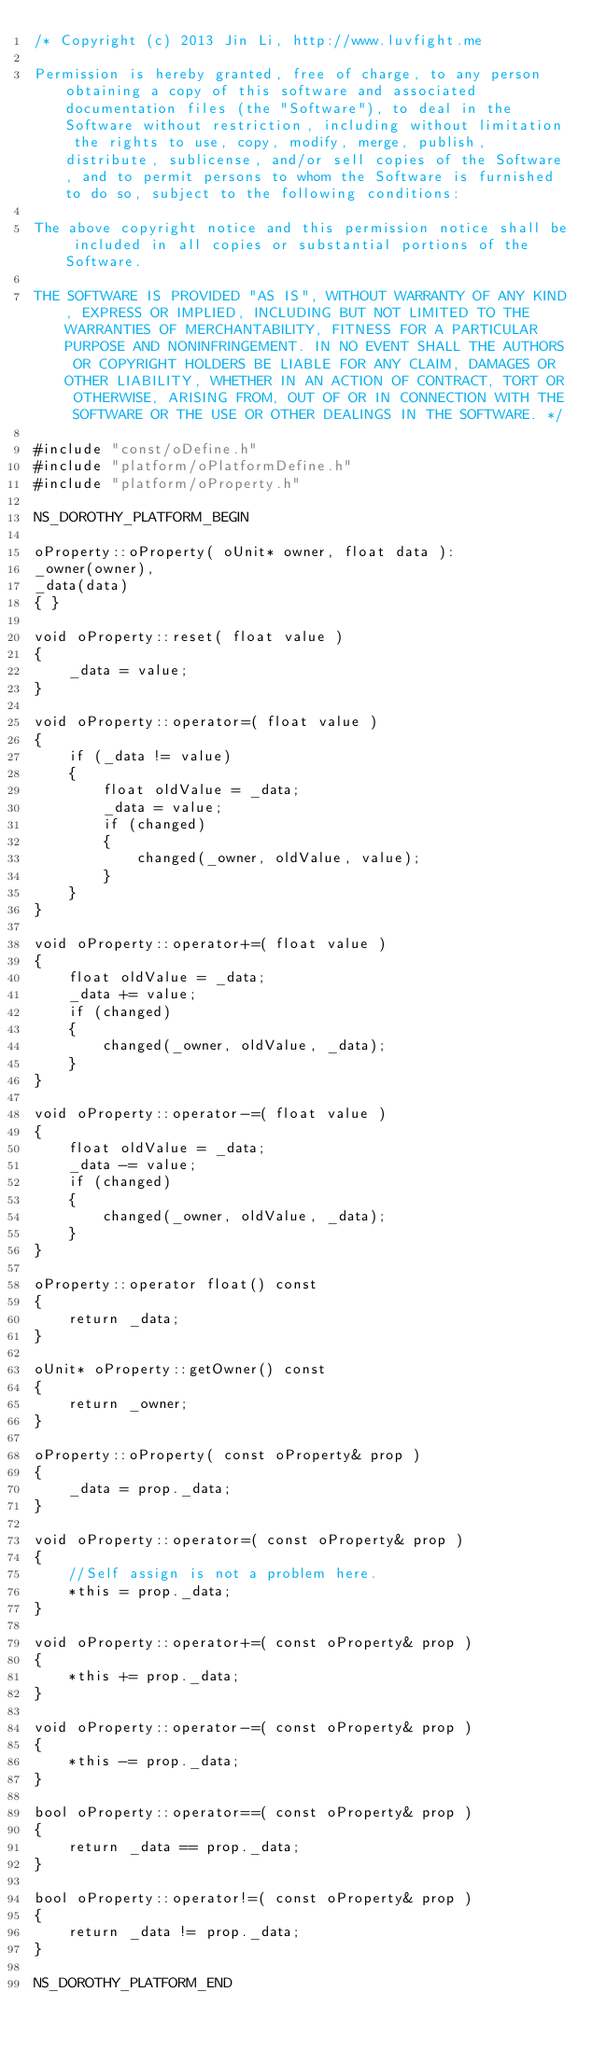Convert code to text. <code><loc_0><loc_0><loc_500><loc_500><_C++_>/* Copyright (c) 2013 Jin Li, http://www.luvfight.me

Permission is hereby granted, free of charge, to any person obtaining a copy of this software and associated documentation files (the "Software"), to deal in the Software without restriction, including without limitation the rights to use, copy, modify, merge, publish, distribute, sublicense, and/or sell copies of the Software, and to permit persons to whom the Software is furnished to do so, subject to the following conditions:

The above copyright notice and this permission notice shall be included in all copies or substantial portions of the Software.

THE SOFTWARE IS PROVIDED "AS IS", WITHOUT WARRANTY OF ANY KIND, EXPRESS OR IMPLIED, INCLUDING BUT NOT LIMITED TO THE WARRANTIES OF MERCHANTABILITY, FITNESS FOR A PARTICULAR PURPOSE AND NONINFRINGEMENT. IN NO EVENT SHALL THE AUTHORS OR COPYRIGHT HOLDERS BE LIABLE FOR ANY CLAIM, DAMAGES OR OTHER LIABILITY, WHETHER IN AN ACTION OF CONTRACT, TORT OR OTHERWISE, ARISING FROM, OUT OF OR IN CONNECTION WITH THE SOFTWARE OR THE USE OR OTHER DEALINGS IN THE SOFTWARE. */

#include "const/oDefine.h"
#include "platform/oPlatformDefine.h"
#include "platform/oProperty.h"

NS_DOROTHY_PLATFORM_BEGIN

oProperty::oProperty( oUnit* owner, float data ):
_owner(owner),
_data(data)
{ }

void oProperty::reset( float value )
{
	_data = value;
}

void oProperty::operator=( float value )
{
	if (_data != value)
	{
		float oldValue = _data;
		_data = value;
		if (changed)
		{
			changed(_owner, oldValue, value);
		}
	}
}

void oProperty::operator+=( float value )
{
	float oldValue = _data;
	_data += value;
	if (changed)
	{
		changed(_owner, oldValue, _data);
	}
}

void oProperty::operator-=( float value )
{
	float oldValue = _data;
	_data -= value;
 	if (changed)
	{
		changed(_owner, oldValue, _data);
	}
}

oProperty::operator float() const
{
	return _data;
}

oUnit* oProperty::getOwner() const
{
	return _owner;
}

oProperty::oProperty( const oProperty& prop )
{
	_data = prop._data;
}

void oProperty::operator=( const oProperty& prop )
{
	//Self assign is not a problem here.
	*this = prop._data;
}

void oProperty::operator+=( const oProperty& prop )
{
	*this += prop._data;
}

void oProperty::operator-=( const oProperty& prop )
{
	*this -= prop._data;
}

bool oProperty::operator==( const oProperty& prop )
{
	return _data == prop._data;
}

bool oProperty::operator!=( const oProperty& prop )
{
	return _data != prop._data;
}

NS_DOROTHY_PLATFORM_END
</code> 